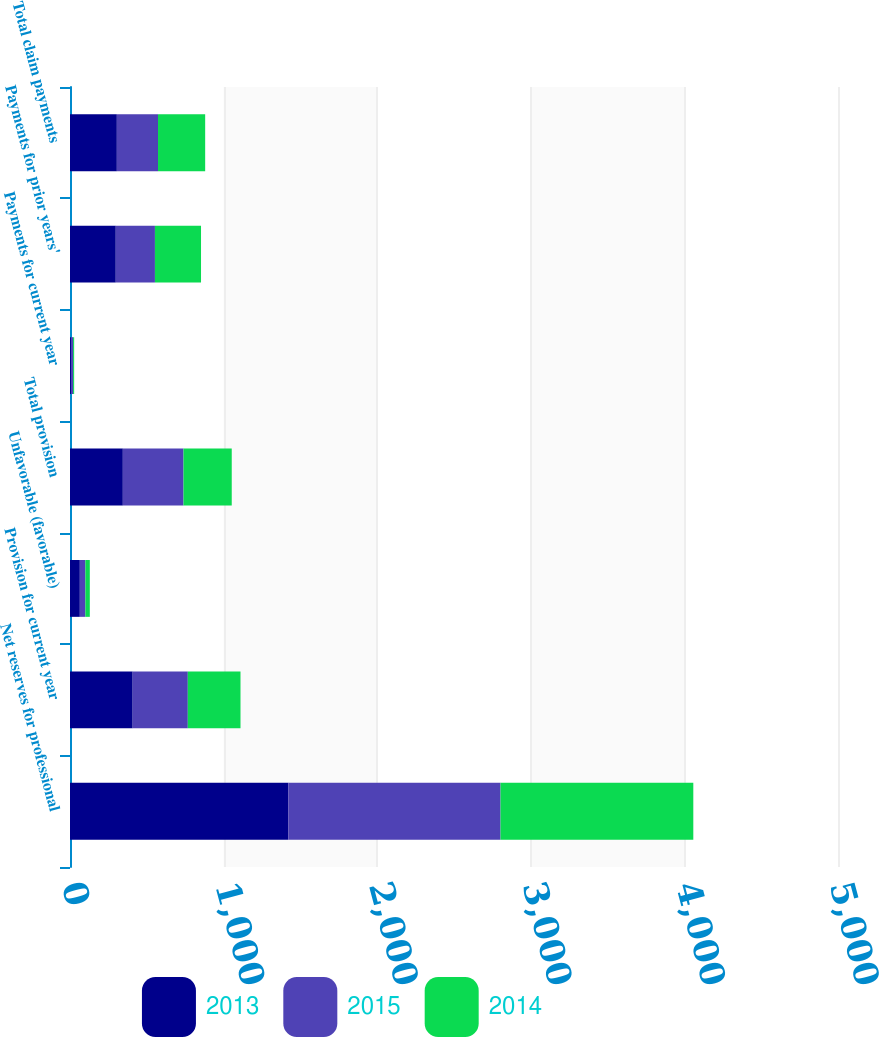<chart> <loc_0><loc_0><loc_500><loc_500><stacked_bar_chart><ecel><fcel>Net reserves for professional<fcel>Provision for current year<fcel>Unfavorable (favorable)<fcel>Total provision<fcel>Payments for current year<fcel>Payments for prior years'<fcel>Total claim payments<nl><fcel>2013<fcel>1421<fcel>408<fcel>64<fcel>344<fcel>7<fcel>298<fcel>305<nl><fcel>2015<fcel>1382<fcel>359<fcel>36<fcel>395<fcel>13<fcel>255<fcel>268<nl><fcel>2014<fcel>1255<fcel>343<fcel>29<fcel>314<fcel>7<fcel>300<fcel>307<nl></chart> 